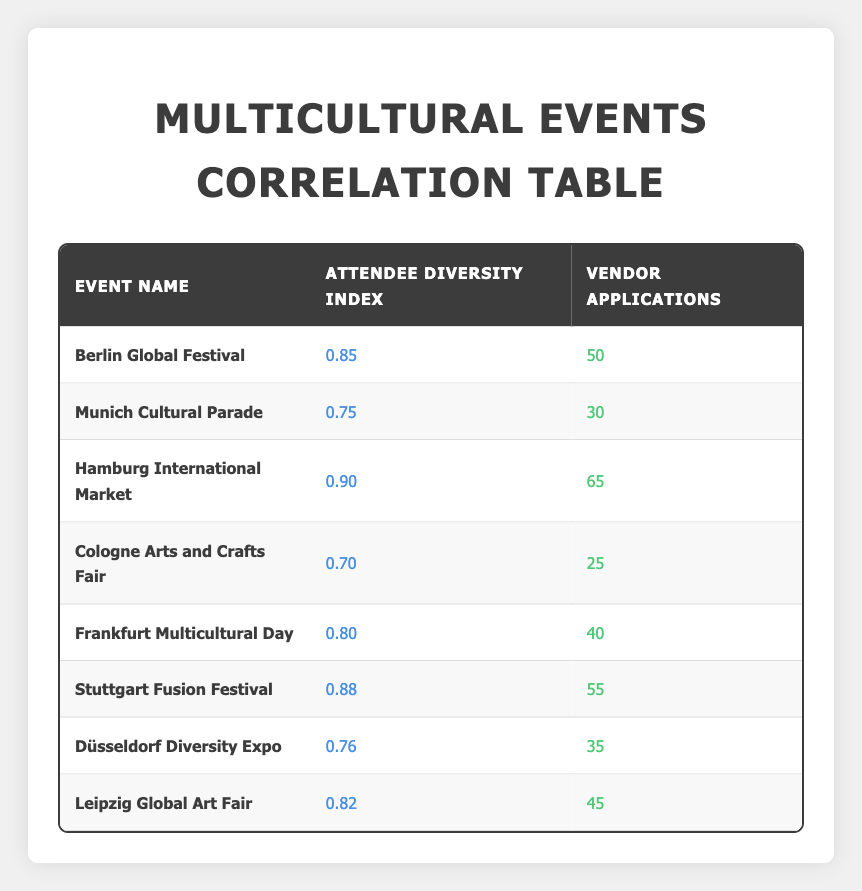What is the attendee diversity index of the Hamburg International Market? The attendee diversity index for the Hamburg International Market is given directly in the table. It states 0.90 next to this event name in the diversity index column.
Answer: 0.90 How many vendor applications were submitted for the Munich Cultural Parade? The number of vendor applications for the Munich Cultural Parade can be found directly under the vendor applications column in the table. It shows 30 applications next to this event name.
Answer: 30 Which event has the highest number of vendor applications? To find the highest number of vendor applications, we look at the vendor applications column in the table and see that the Hamburg International Market has 65 applications, which is the highest when compared to all other events listed.
Answer: Hamburg International Market What is the average attendee diversity index of all the events listed? To calculate the average, we first sum the diversity indices (0.85 + 0.75 + 0.90 + 0.70 + 0.80 + 0.88 + 0.76 + 0.82) which equals 5.56. Then, we divide this sum by 8 (the number of events), giving an average of 5.56 / 8 = 0.695.
Answer: 0.695 Is the statement true that the Stuttgart Fusion Festival has more vendor applications than the Frankfurt Multicultural Day? We check the vendor applications for both events: Stuttgart Fusion Festival has 55 applications, while Frankfurt Multicultural Day has 40 applications. Since 55 is greater than 40, the statement is indeed true.
Answer: Yes What is the total number of vendor applications across all events? We sum the vendor applications for all events listed in the table: (50 + 30 + 65 + 25 + 40 + 55 + 35 + 45) = 340 vendor applications.
Answer: 340 Which event has the lowest attendee diversity index? By reviewing the diversity index column, we find the lowest value is for the Cologne Arts and Crafts Fair, which has an index of 0.70.
Answer: Cologne Arts and Crafts Fair Is there an event with an attendee diversity index above 0.85 that has less than 50 vendor applications? We check the events with an index above 0.85: Berlin Global Festival (0.85, 50), Hamburg International Market (0.90, 65), and Stuttgart Fusion Festival (0.88, 55). All of these events have vendor applications equal to or above 50, thus no such event exists.
Answer: No 